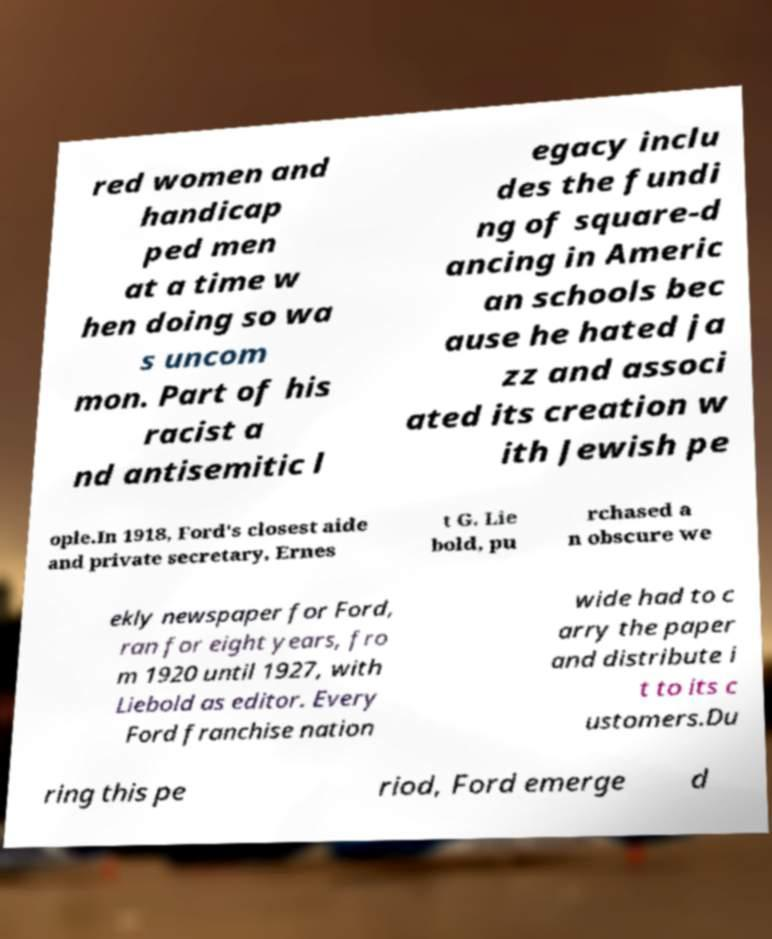Can you read and provide the text displayed in the image?This photo seems to have some interesting text. Can you extract and type it out for me? red women and handicap ped men at a time w hen doing so wa s uncom mon. Part of his racist a nd antisemitic l egacy inclu des the fundi ng of square-d ancing in Americ an schools bec ause he hated ja zz and associ ated its creation w ith Jewish pe ople.In 1918, Ford's closest aide and private secretary, Ernes t G. Lie bold, pu rchased a n obscure we ekly newspaper for Ford, ran for eight years, fro m 1920 until 1927, with Liebold as editor. Every Ford franchise nation wide had to c arry the paper and distribute i t to its c ustomers.Du ring this pe riod, Ford emerge d 